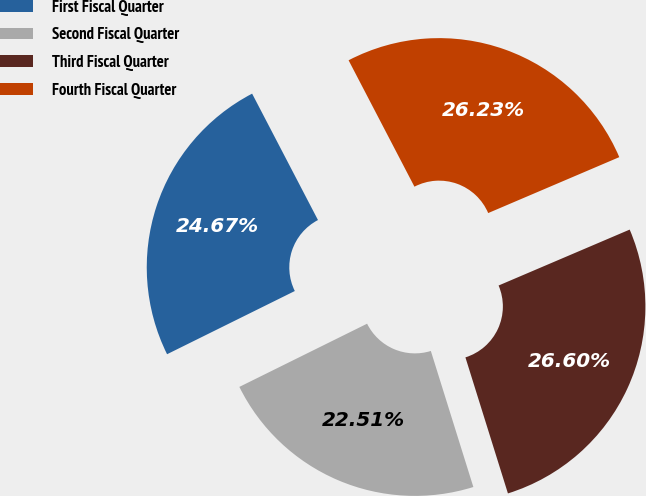Convert chart. <chart><loc_0><loc_0><loc_500><loc_500><pie_chart><fcel>First Fiscal Quarter<fcel>Second Fiscal Quarter<fcel>Third Fiscal Quarter<fcel>Fourth Fiscal Quarter<nl><fcel>24.67%<fcel>22.51%<fcel>26.6%<fcel>26.23%<nl></chart> 